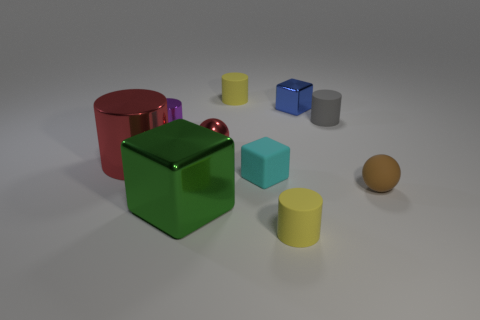Subtract all tiny gray rubber cylinders. How many cylinders are left? 4 Subtract all yellow cylinders. How many cylinders are left? 3 Subtract all green balls. How many yellow cylinders are left? 2 Subtract all cyan cylinders. Subtract all purple spheres. How many cylinders are left? 5 Subtract all cubes. How many objects are left? 7 Add 6 purple metallic cylinders. How many purple metallic cylinders exist? 7 Subtract 1 brown balls. How many objects are left? 9 Subtract all yellow matte things. Subtract all brown rubber spheres. How many objects are left? 7 Add 5 small gray objects. How many small gray objects are left? 6 